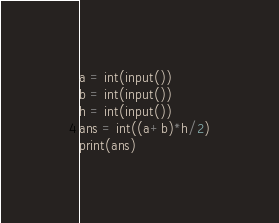<code> <loc_0><loc_0><loc_500><loc_500><_Python_>a = int(input())
b = int(input())
h = int(input())
ans = int((a+b)*h/2)
print(ans)</code> 